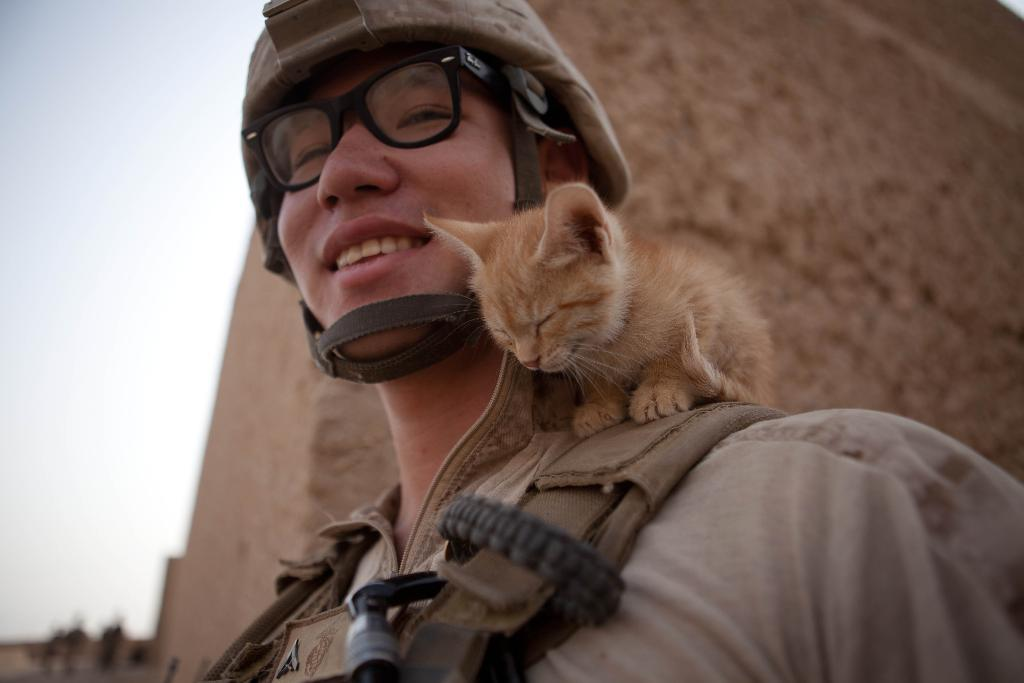Who is present in the image? There is a woman in the image. What is the woman wearing on her head? The woman is wearing a helmet. What type of eyewear is the woman wearing? The woman is wearing spectacles. What type of animal is on the woman's shoulder? There is a kitten on the woman's shoulder. What can be seen in the background of the image? There is a structure in the background of the image. What is the condition of the sky in the image? The sky is clear in the image. What type of songs can be heard being sung by the kitten in the image? There is no indication in the image that the kitten is singing songs, as kittens do not have the ability to sing. 